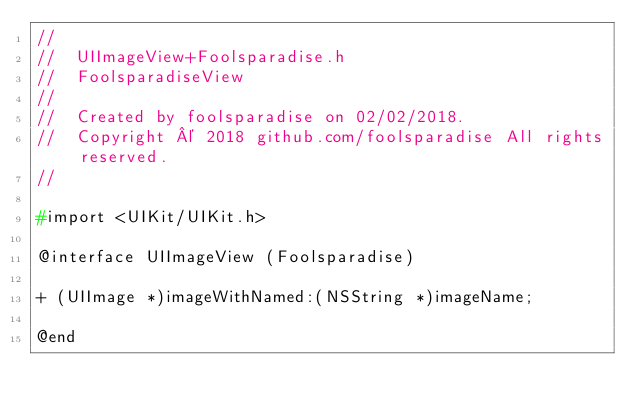<code> <loc_0><loc_0><loc_500><loc_500><_C_>//
//  UIImageView+Foolsparadise.h
//  FoolsparadiseView
//
//  Created by foolsparadise on 02/02/2018.
//  Copyright © 2018 github.com/foolsparadise All rights reserved.
//

#import <UIKit/UIKit.h>

@interface UIImageView (Foolsparadise)

+ (UIImage *)imageWithNamed:(NSString *)imageName;

@end
</code> 